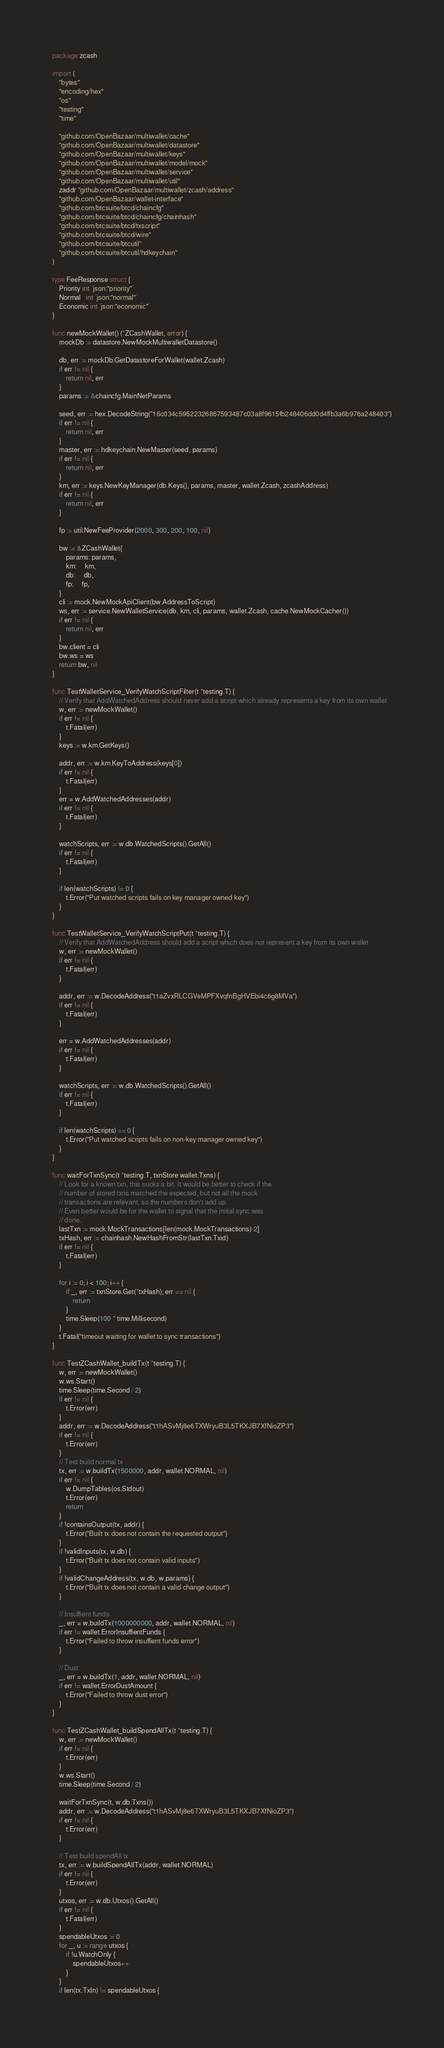<code> <loc_0><loc_0><loc_500><loc_500><_Go_>package zcash

import (
	"bytes"
	"encoding/hex"
	"os"
	"testing"
	"time"

	"github.com/OpenBazaar/multiwallet/cache"
	"github.com/OpenBazaar/multiwallet/datastore"
	"github.com/OpenBazaar/multiwallet/keys"
	"github.com/OpenBazaar/multiwallet/model/mock"
	"github.com/OpenBazaar/multiwallet/service"
	"github.com/OpenBazaar/multiwallet/util"
	zaddr "github.com/OpenBazaar/multiwallet/zcash/address"
	"github.com/OpenBazaar/wallet-interface"
	"github.com/btcsuite/btcd/chaincfg"
	"github.com/btcsuite/btcd/chaincfg/chainhash"
	"github.com/btcsuite/btcd/txscript"
	"github.com/btcsuite/btcd/wire"
	"github.com/btcsuite/btcutil"
	"github.com/btcsuite/btcutil/hdkeychain"
)

type FeeResponse struct {
	Priority int `json:"priority"`
	Normal   int `json:"normal"`
	Economic int `json:"economic"`
}

func newMockWallet() (*ZCashWallet, error) {
	mockDb := datastore.NewMockMultiwalletDatastore()

	db, err := mockDb.GetDatastoreForWallet(wallet.Zcash)
	if err != nil {
		return nil, err
	}
	params := &chaincfg.MainNetParams

	seed, err := hex.DecodeString("16c034c59522326867593487c03a8f9615fb248406dd0d4ffb3a6b976a248403")
	if err != nil {
		return nil, err
	}
	master, err := hdkeychain.NewMaster(seed, params)
	if err != nil {
		return nil, err
	}
	km, err := keys.NewKeyManager(db.Keys(), params, master, wallet.Zcash, zcashAddress)
	if err != nil {
		return nil, err
	}

	fp := util.NewFeeProvider(2000, 300, 200, 100, nil)

	bw := &ZCashWallet{
		params: params,
		km:     km,
		db:     db,
		fp:     fp,
	}
	cli := mock.NewMockApiClient(bw.AddressToScript)
	ws, err := service.NewWalletService(db, km, cli, params, wallet.Zcash, cache.NewMockCacher())
	if err != nil {
		return nil, err
	}
	bw.client = cli
	bw.ws = ws
	return bw, nil
}

func TestWalletService_VerifyWatchScriptFilter(t *testing.T) {
	// Verify that AddWatchedAddress should never add a script which already represents a key from its own wallet
	w, err := newMockWallet()
	if err != nil {
		t.Fatal(err)
	}
	keys := w.km.GetKeys()

	addr, err := w.km.KeyToAddress(keys[0])
	if err != nil {
		t.Fatal(err)
	}
	err = w.AddWatchedAddresses(addr)
	if err != nil {
		t.Fatal(err)
	}

	watchScripts, err := w.db.WatchedScripts().GetAll()
	if err != nil {
		t.Fatal(err)
	}

	if len(watchScripts) != 0 {
		t.Error("Put watched scripts fails on key manager owned key")
	}
}

func TestWalletService_VerifyWatchScriptPut(t *testing.T) {
	// Verify that AddWatchedAddress should add a script which does not represent a key from its own wallet
	w, err := newMockWallet()
	if err != nil {
		t.Fatal(err)
	}

	addr, err := w.DecodeAddress("t1aZvxRLCGVeMPFXvqfnBgHVEbi4c6g8MVa")
	if err != nil {
		t.Fatal(err)
	}

	err = w.AddWatchedAddresses(addr)
	if err != nil {
		t.Fatal(err)
	}

	watchScripts, err := w.db.WatchedScripts().GetAll()
	if err != nil {
		t.Fatal(err)
	}

	if len(watchScripts) == 0 {
		t.Error("Put watched scripts fails on non-key manager owned key")
	}
}

func waitForTxnSync(t *testing.T, txnStore wallet.Txns) {
	// Look for a known txn, this sucks a bit. It would be better to check if the
	// number of stored txns matched the expected, but not all the mock
	// transactions are relevant, so the numbers don't add up.
	// Even better would be for the wallet to signal that the initial sync was
	// done.
	lastTxn := mock.MockTransactions[len(mock.MockTransactions)-2]
	txHash, err := chainhash.NewHashFromStr(lastTxn.Txid)
	if err != nil {
		t.Fatal(err)
	}

	for i := 0; i < 100; i++ {
		if _, err := txnStore.Get(*txHash); err == nil {
			return
		}
		time.Sleep(100 * time.Millisecond)
	}
	t.Fatal("timeout waiting for wallet to sync transactions")
}

func TestZCashWallet_buildTx(t *testing.T) {
	w, err := newMockWallet()
	w.ws.Start()
	time.Sleep(time.Second / 2)
	if err != nil {
		t.Error(err)
	}
	addr, err := w.DecodeAddress("t1hASvMj8e6TXWryuB3L5TKXJB7XfNioZP3")
	if err != nil {
		t.Error(err)
	}
	// Test build normal tx
	tx, err := w.buildTx(1500000, addr, wallet.NORMAL, nil)
	if err != nil {
		w.DumpTables(os.Stdout)
		t.Error(err)
		return
	}
	if !containsOutput(tx, addr) {
		t.Error("Built tx does not contain the requested output")
	}
	if !validInputs(tx, w.db) {
		t.Error("Built tx does not contain valid inputs")
	}
	if !validChangeAddress(tx, w.db, w.params) {
		t.Error("Built tx does not contain a valid change output")
	}

	// Insuffient funds
	_, err = w.buildTx(1000000000, addr, wallet.NORMAL, nil)
	if err != wallet.ErrorInsuffientFunds {
		t.Error("Failed to throw insuffient funds error")
	}

	// Dust
	_, err = w.buildTx(1, addr, wallet.NORMAL, nil)
	if err != wallet.ErrorDustAmount {
		t.Error("Failed to throw dust error")
	}
}

func TestZCashWallet_buildSpendAllTx(t *testing.T) {
	w, err := newMockWallet()
	if err != nil {
		t.Error(err)
	}
	w.ws.Start()
	time.Sleep(time.Second / 2)

	waitForTxnSync(t, w.db.Txns())
	addr, err := w.DecodeAddress("t1hASvMj8e6TXWryuB3L5TKXJB7XfNioZP3")
	if err != nil {
		t.Error(err)
	}

	// Test build spendAll tx
	tx, err := w.buildSpendAllTx(addr, wallet.NORMAL)
	if err != nil {
		t.Error(err)
	}
	utxos, err := w.db.Utxos().GetAll()
	if err != nil {
		t.Fatal(err)
	}
	spendableUtxos := 0
	for _, u := range utxos {
		if !u.WatchOnly {
			spendableUtxos++
		}
	}
	if len(tx.TxIn) != spendableUtxos {</code> 